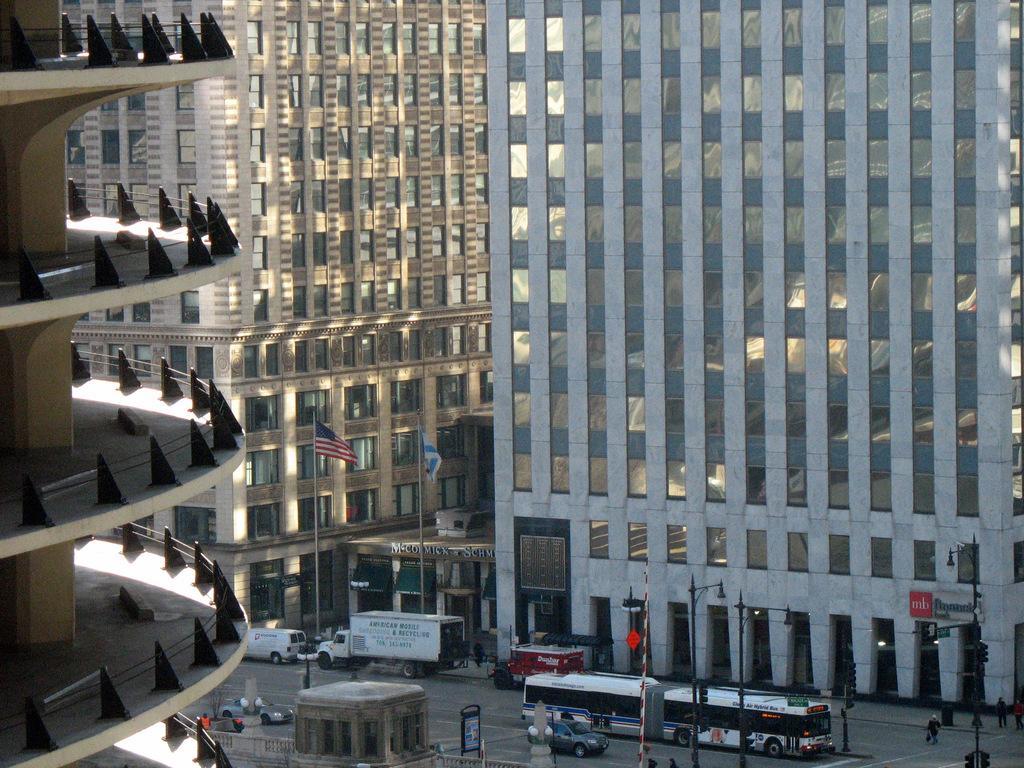How would you summarize this image in a sentence or two? In this image there are buildings and flags. At the bottom there is a road and we can see vehicles on the road. There are poles and traffic lights. We can see people. 